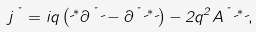<formula> <loc_0><loc_0><loc_500><loc_500>j ^ { \nu } = i q \left ( \psi ^ { * } \partial ^ { \nu } \psi - \partial ^ { \nu } \psi ^ { * } \psi \right ) - 2 q ^ { 2 } A ^ { \nu } \psi ^ { * } \psi ,</formula> 